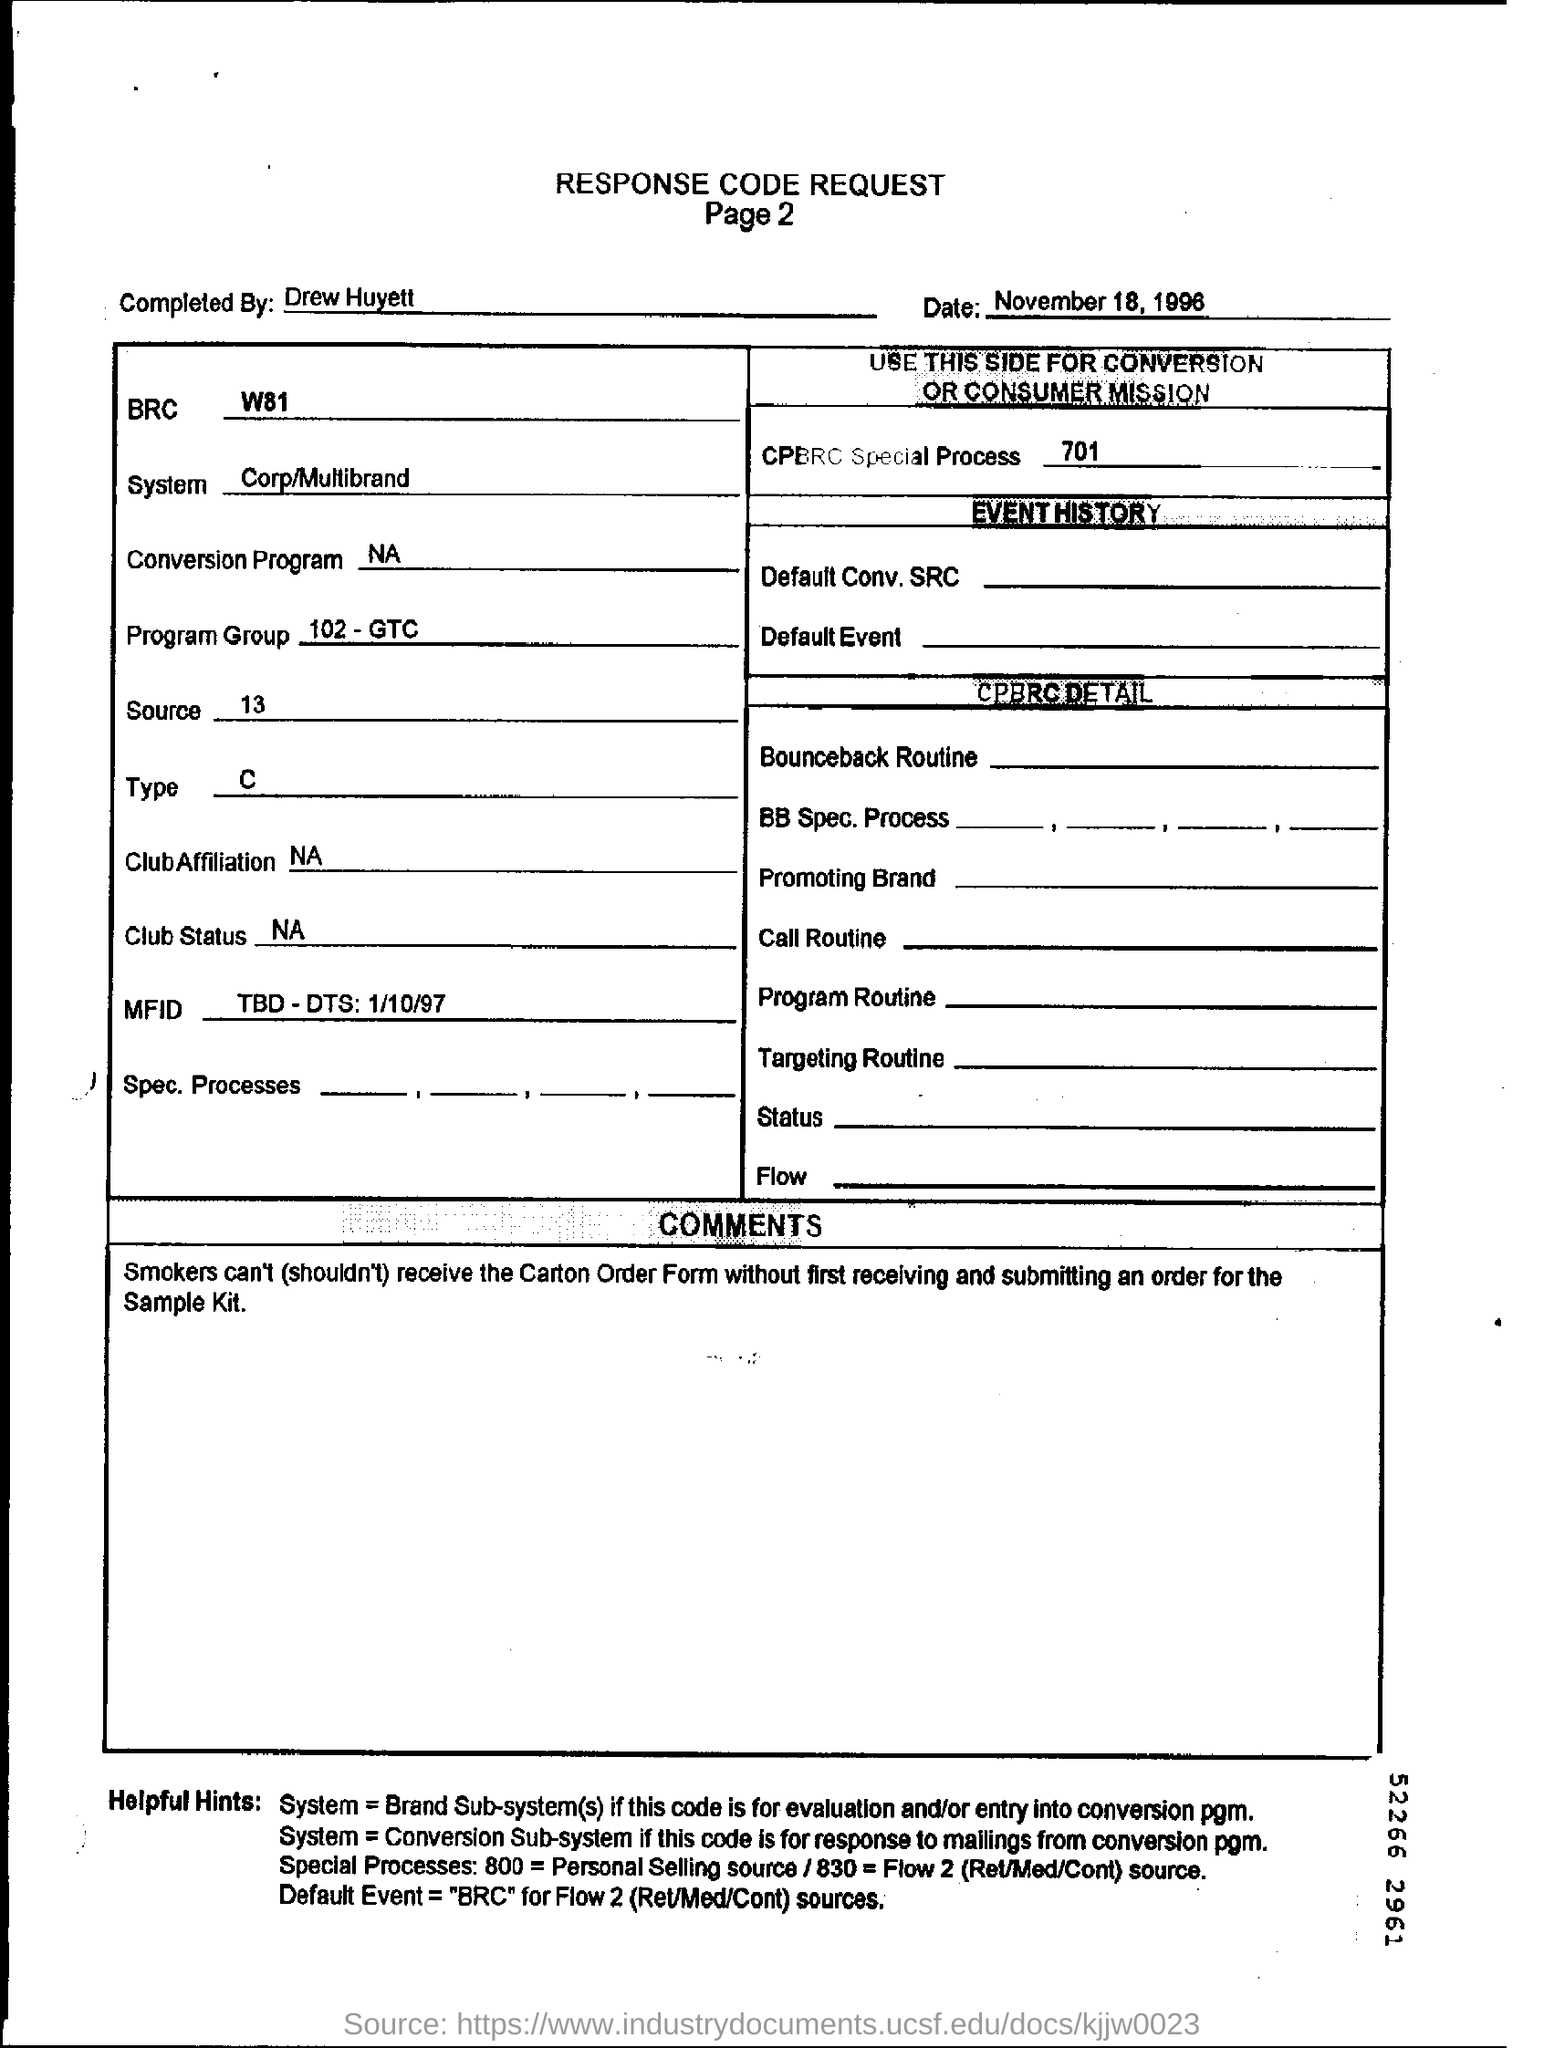What type of form is this?
Keep it short and to the point. RESPONSE CODE REQUEST. By whom is this document completed?
Keep it short and to the point. Drew Huyett. What is the BRC mentioned?
Your response must be concise. W81. 